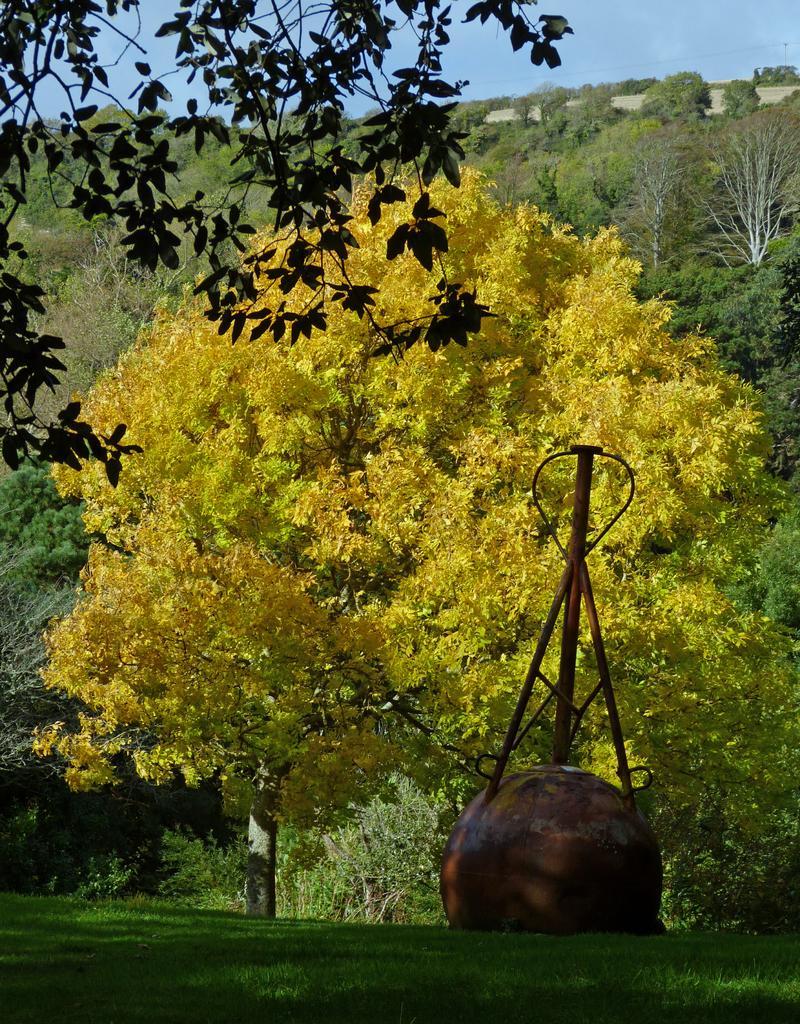Describe this image in one or two sentences. In this image we can see some trees, plants, and a roller, also we can see the sky. 